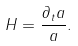<formula> <loc_0><loc_0><loc_500><loc_500>H = \frac { \partial _ { t } a } { a } .</formula> 